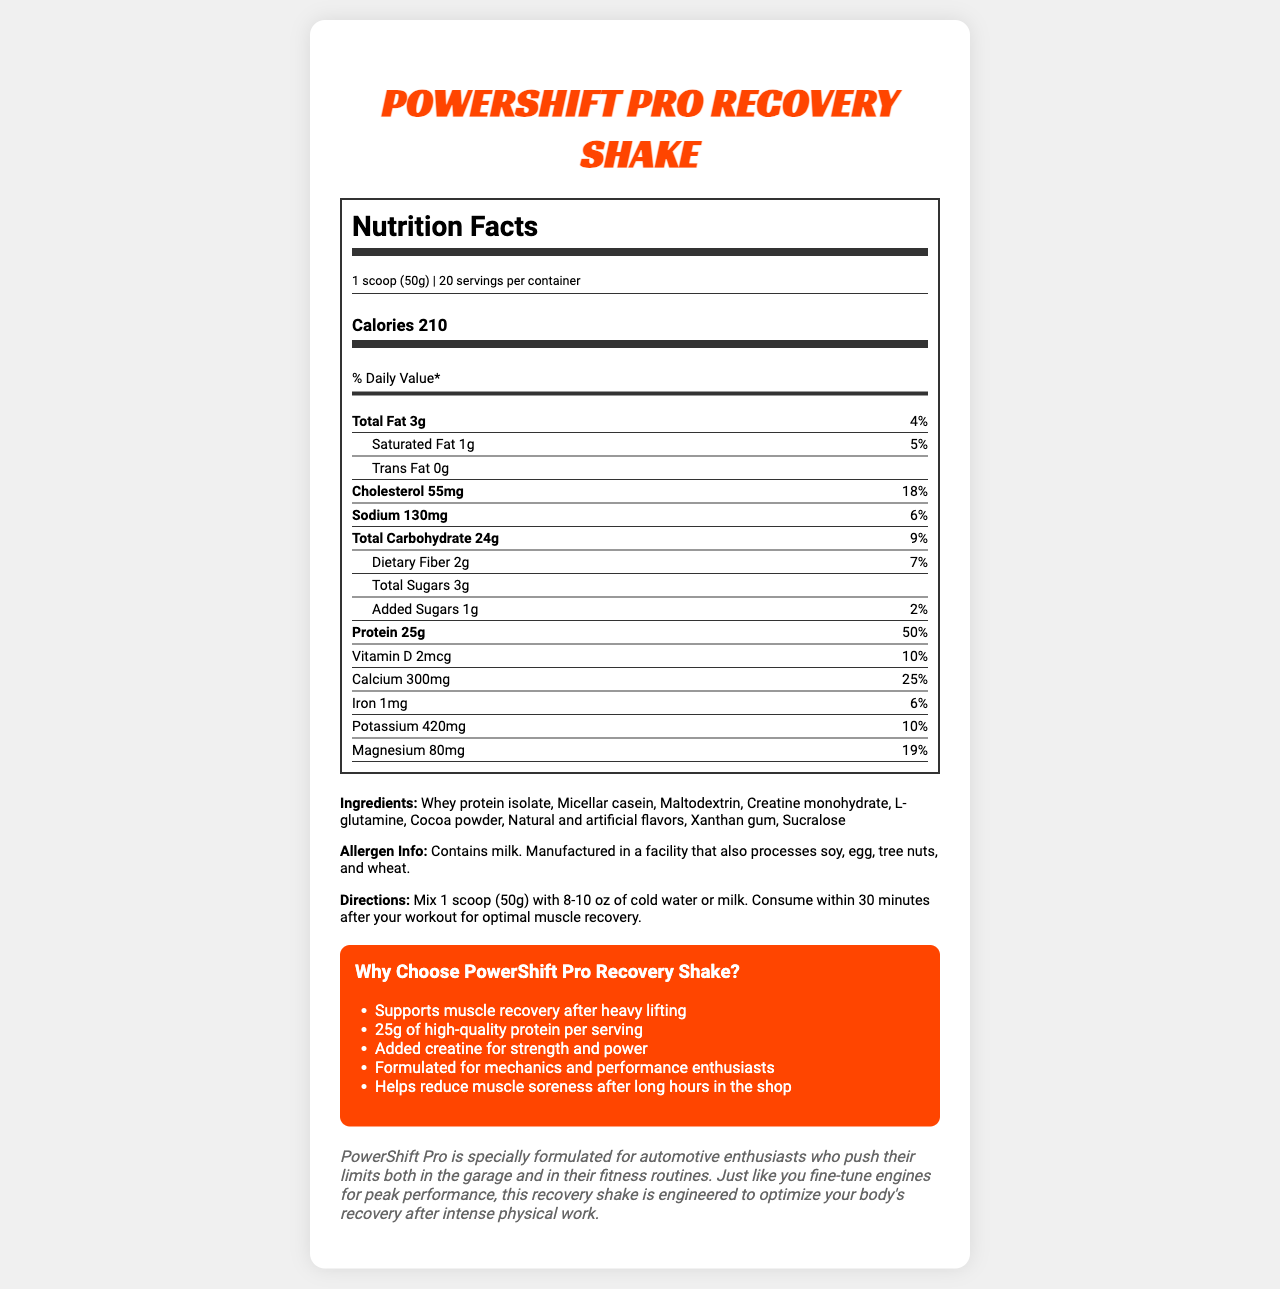what is the serving size? The document mentions the serving size as 1 scoop (50g) in the Nutrition Facts section.
Answer: 1 scoop (50g) how many calories are in one serving? The calorie information is provided under the Nutrition Facts section and states that one serving contains 210 calories.
Answer: 210 what is the daily value percentage for protein? In the Nutritional Facts section, it states that the protein daily value percentage is 50%.
Answer: 50% how much sodium is in each serving? The sodium content per serving is listed as 130mg in the Nutrition Facts section.
Answer: 130mg what allergens are present in this recovery shake? The allergen information specifies that the product contains milk.
Answer: Milk how many servings are in one container? A. 10 B. 15 C. 20 D. 25 The document states that there are 20 servings per container in the Nutritional Facts section.
Answer: C. 20 what is the amount of added sugars per serving? A. 0g B. 1g C. 2g D. 3g Under the Nutritional Facts, it specifies that the amount of added sugars per serving is 1g.
Answer: B. 1g is there any trans fat in this recovery shake? The Nutritional Facts section indicates that the amount of trans fat is 0g.
Answer: No Who is the target audience for PowerShift Pro Recovery Shake? The brand story mentions that PowerShift Pro is specially formulated for automotive enthusiasts who push their limits both in the garage and in their fitness routines.
Answer: Automotive enthusiasts who push their limits both in the garage and in their fitness routines Summarize the main idea of the PowerShift Pro Recovery Shake document. The document includes all relevant details about the product's nutritional value, ingredients, benefits, and target audience, emphasizing its use for muscle recovery and strength.
Answer: The document provides detailed nutritional information, ingredients, allergen info, and marketing claims for PowerShift Pro Recovery Shake. It highlights the high protein content, added creatine, and the product's suitability for muscle recovery after heavy physical activity, targeting mechanics and performance enthusiasts. How much vitamin C does the PowerShift Pro Recovery Shake contain? The document does not provide any information about the vitamin C content in the PowerShift Pro Recovery Shake.
Answer: Not enough information 